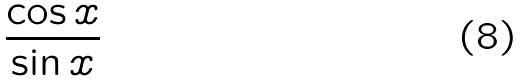<formula> <loc_0><loc_0><loc_500><loc_500>\frac { \cos x } { \sin x }</formula> 